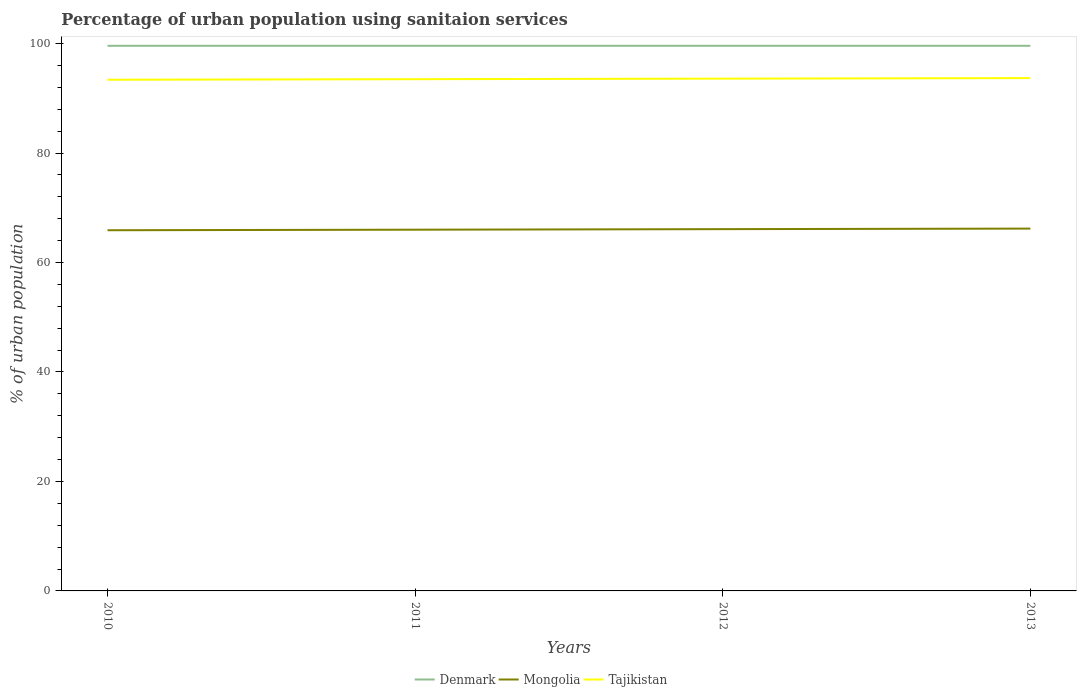How many different coloured lines are there?
Provide a succinct answer. 3. Does the line corresponding to Denmark intersect with the line corresponding to Tajikistan?
Provide a succinct answer. No. Is the number of lines equal to the number of legend labels?
Your response must be concise. Yes. Across all years, what is the maximum percentage of urban population using sanitaion services in Mongolia?
Keep it short and to the point. 65.9. What is the total percentage of urban population using sanitaion services in Mongolia in the graph?
Give a very brief answer. -0.3. What is the difference between the highest and the second highest percentage of urban population using sanitaion services in Mongolia?
Keep it short and to the point. 0.3. What is the difference between the highest and the lowest percentage of urban population using sanitaion services in Mongolia?
Make the answer very short. 2. Are the values on the major ticks of Y-axis written in scientific E-notation?
Keep it short and to the point. No. Where does the legend appear in the graph?
Make the answer very short. Bottom center. What is the title of the graph?
Give a very brief answer. Percentage of urban population using sanitaion services. Does "South Africa" appear as one of the legend labels in the graph?
Provide a short and direct response. No. What is the label or title of the Y-axis?
Your response must be concise. % of urban population. What is the % of urban population in Denmark in 2010?
Your answer should be compact. 99.6. What is the % of urban population of Mongolia in 2010?
Offer a very short reply. 65.9. What is the % of urban population in Tajikistan in 2010?
Your response must be concise. 93.4. What is the % of urban population of Denmark in 2011?
Your answer should be very brief. 99.6. What is the % of urban population of Mongolia in 2011?
Your answer should be very brief. 66. What is the % of urban population in Tajikistan in 2011?
Make the answer very short. 93.5. What is the % of urban population in Denmark in 2012?
Ensure brevity in your answer.  99.6. What is the % of urban population of Mongolia in 2012?
Make the answer very short. 66.1. What is the % of urban population of Tajikistan in 2012?
Provide a short and direct response. 93.6. What is the % of urban population in Denmark in 2013?
Your answer should be very brief. 99.6. What is the % of urban population of Mongolia in 2013?
Provide a succinct answer. 66.2. What is the % of urban population of Tajikistan in 2013?
Provide a short and direct response. 93.7. Across all years, what is the maximum % of urban population of Denmark?
Make the answer very short. 99.6. Across all years, what is the maximum % of urban population of Mongolia?
Your answer should be compact. 66.2. Across all years, what is the maximum % of urban population in Tajikistan?
Offer a very short reply. 93.7. Across all years, what is the minimum % of urban population in Denmark?
Your answer should be compact. 99.6. Across all years, what is the minimum % of urban population in Mongolia?
Make the answer very short. 65.9. Across all years, what is the minimum % of urban population of Tajikistan?
Ensure brevity in your answer.  93.4. What is the total % of urban population of Denmark in the graph?
Provide a succinct answer. 398.4. What is the total % of urban population in Mongolia in the graph?
Give a very brief answer. 264.2. What is the total % of urban population of Tajikistan in the graph?
Your response must be concise. 374.2. What is the difference between the % of urban population of Denmark in 2010 and that in 2011?
Provide a succinct answer. 0. What is the difference between the % of urban population of Mongolia in 2010 and that in 2011?
Ensure brevity in your answer.  -0.1. What is the difference between the % of urban population of Denmark in 2010 and that in 2012?
Your answer should be compact. 0. What is the difference between the % of urban population of Mongolia in 2010 and that in 2012?
Make the answer very short. -0.2. What is the difference between the % of urban population of Denmark in 2010 and that in 2013?
Keep it short and to the point. 0. What is the difference between the % of urban population in Denmark in 2011 and that in 2012?
Provide a succinct answer. 0. What is the difference between the % of urban population in Mongolia in 2011 and that in 2012?
Provide a short and direct response. -0.1. What is the difference between the % of urban population in Denmark in 2011 and that in 2013?
Offer a terse response. 0. What is the difference between the % of urban population in Mongolia in 2011 and that in 2013?
Your answer should be very brief. -0.2. What is the difference between the % of urban population in Mongolia in 2012 and that in 2013?
Your answer should be very brief. -0.1. What is the difference between the % of urban population of Tajikistan in 2012 and that in 2013?
Your response must be concise. -0.1. What is the difference between the % of urban population of Denmark in 2010 and the % of urban population of Mongolia in 2011?
Your answer should be compact. 33.6. What is the difference between the % of urban population of Denmark in 2010 and the % of urban population of Tajikistan in 2011?
Offer a very short reply. 6.1. What is the difference between the % of urban population in Mongolia in 2010 and the % of urban population in Tajikistan in 2011?
Ensure brevity in your answer.  -27.6. What is the difference between the % of urban population of Denmark in 2010 and the % of urban population of Mongolia in 2012?
Ensure brevity in your answer.  33.5. What is the difference between the % of urban population of Mongolia in 2010 and the % of urban population of Tajikistan in 2012?
Give a very brief answer. -27.7. What is the difference between the % of urban population in Denmark in 2010 and the % of urban population in Mongolia in 2013?
Provide a short and direct response. 33.4. What is the difference between the % of urban population of Denmark in 2010 and the % of urban population of Tajikistan in 2013?
Ensure brevity in your answer.  5.9. What is the difference between the % of urban population in Mongolia in 2010 and the % of urban population in Tajikistan in 2013?
Offer a very short reply. -27.8. What is the difference between the % of urban population in Denmark in 2011 and the % of urban population in Mongolia in 2012?
Offer a very short reply. 33.5. What is the difference between the % of urban population of Denmark in 2011 and the % of urban population of Tajikistan in 2012?
Offer a terse response. 6. What is the difference between the % of urban population in Mongolia in 2011 and the % of urban population in Tajikistan in 2012?
Give a very brief answer. -27.6. What is the difference between the % of urban population of Denmark in 2011 and the % of urban population of Mongolia in 2013?
Your answer should be compact. 33.4. What is the difference between the % of urban population in Mongolia in 2011 and the % of urban population in Tajikistan in 2013?
Keep it short and to the point. -27.7. What is the difference between the % of urban population in Denmark in 2012 and the % of urban population in Mongolia in 2013?
Make the answer very short. 33.4. What is the difference between the % of urban population in Mongolia in 2012 and the % of urban population in Tajikistan in 2013?
Your answer should be compact. -27.6. What is the average % of urban population in Denmark per year?
Your answer should be compact. 99.6. What is the average % of urban population in Mongolia per year?
Your answer should be very brief. 66.05. What is the average % of urban population of Tajikistan per year?
Your answer should be compact. 93.55. In the year 2010, what is the difference between the % of urban population in Denmark and % of urban population in Mongolia?
Provide a succinct answer. 33.7. In the year 2010, what is the difference between the % of urban population of Mongolia and % of urban population of Tajikistan?
Offer a terse response. -27.5. In the year 2011, what is the difference between the % of urban population in Denmark and % of urban population in Mongolia?
Your response must be concise. 33.6. In the year 2011, what is the difference between the % of urban population of Denmark and % of urban population of Tajikistan?
Your response must be concise. 6.1. In the year 2011, what is the difference between the % of urban population of Mongolia and % of urban population of Tajikistan?
Offer a very short reply. -27.5. In the year 2012, what is the difference between the % of urban population in Denmark and % of urban population in Mongolia?
Provide a short and direct response. 33.5. In the year 2012, what is the difference between the % of urban population in Denmark and % of urban population in Tajikistan?
Your answer should be compact. 6. In the year 2012, what is the difference between the % of urban population of Mongolia and % of urban population of Tajikistan?
Provide a succinct answer. -27.5. In the year 2013, what is the difference between the % of urban population of Denmark and % of urban population of Mongolia?
Keep it short and to the point. 33.4. In the year 2013, what is the difference between the % of urban population of Denmark and % of urban population of Tajikistan?
Provide a short and direct response. 5.9. In the year 2013, what is the difference between the % of urban population of Mongolia and % of urban population of Tajikistan?
Provide a short and direct response. -27.5. What is the ratio of the % of urban population of Denmark in 2010 to that in 2011?
Your answer should be very brief. 1. What is the ratio of the % of urban population in Mongolia in 2010 to that in 2011?
Offer a very short reply. 1. What is the ratio of the % of urban population of Denmark in 2010 to that in 2012?
Offer a very short reply. 1. What is the ratio of the % of urban population in Tajikistan in 2010 to that in 2012?
Make the answer very short. 1. What is the ratio of the % of urban population in Mongolia in 2010 to that in 2013?
Your response must be concise. 1. What is the ratio of the % of urban population of Denmark in 2011 to that in 2012?
Offer a very short reply. 1. What is the ratio of the % of urban population in Tajikistan in 2011 to that in 2012?
Make the answer very short. 1. What is the ratio of the % of urban population of Denmark in 2011 to that in 2013?
Provide a succinct answer. 1. What is the ratio of the % of urban population in Mongolia in 2011 to that in 2013?
Your answer should be very brief. 1. What is the ratio of the % of urban population of Tajikistan in 2011 to that in 2013?
Offer a terse response. 1. What is the ratio of the % of urban population in Denmark in 2012 to that in 2013?
Provide a succinct answer. 1. What is the ratio of the % of urban population in Mongolia in 2012 to that in 2013?
Your response must be concise. 1. What is the ratio of the % of urban population in Tajikistan in 2012 to that in 2013?
Your response must be concise. 1. What is the difference between the highest and the second highest % of urban population of Denmark?
Offer a terse response. 0. What is the difference between the highest and the lowest % of urban population of Denmark?
Your answer should be compact. 0. What is the difference between the highest and the lowest % of urban population in Mongolia?
Provide a short and direct response. 0.3. 